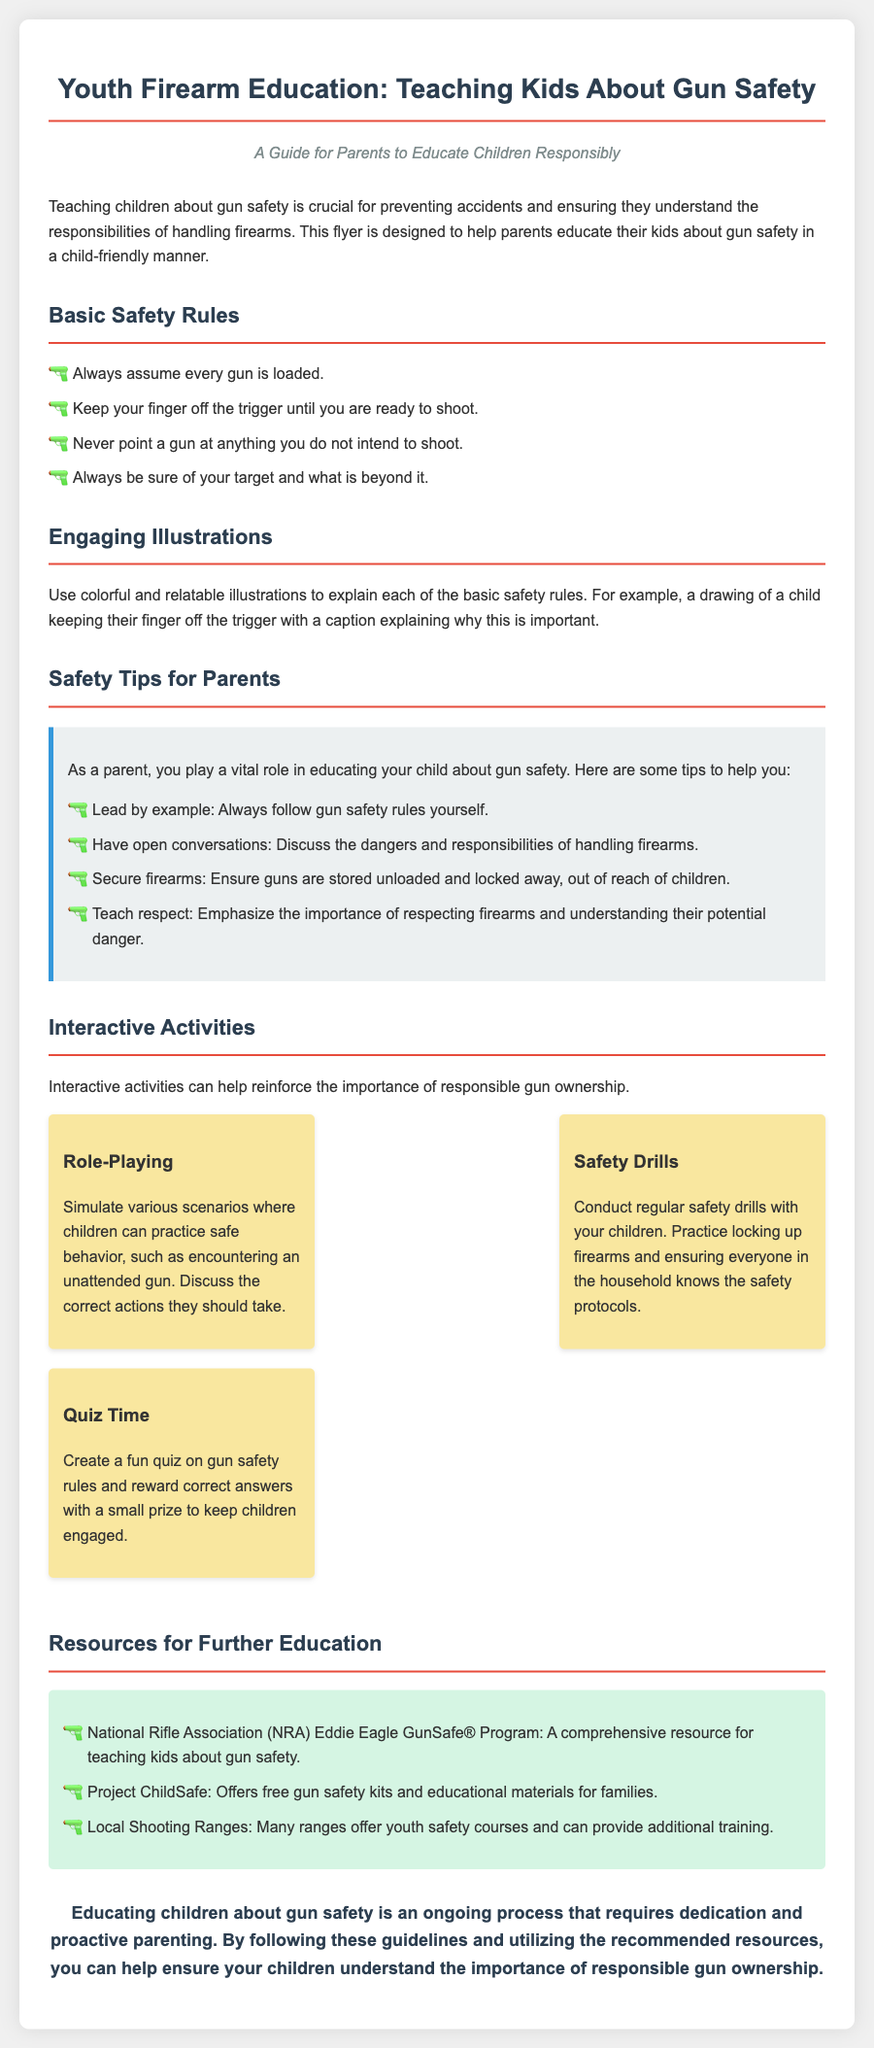What are the basic safety rules? The document lists four basic safety rules that are crucial for firearm education.
Answer: Always assume every gun is loaded, Keep your finger off the trigger until you are ready to shoot, Never point a gun at anything you do not intend to shoot, Always be sure of your target and what is beyond it What role do parents play in educating children on gun safety? The document emphasizes the importance of parents in the education process, stating that they lead by example and have open conversations.
Answer: Lead by example How many interactive activities are suggested in the document? The document describes three interactive activities aimed at reinforcing gun safety education.
Answer: Three What color is used for the safety tips background? The document specifies a light color that serves as the background for the safety tips section.
Answer: Light gray What organization offers the Eddie Eagle GunSafe® Program? The document names a specific organization that provides resources for teaching kids about gun safety through the Eddie Eagle program.
Answer: National Rifle Association 